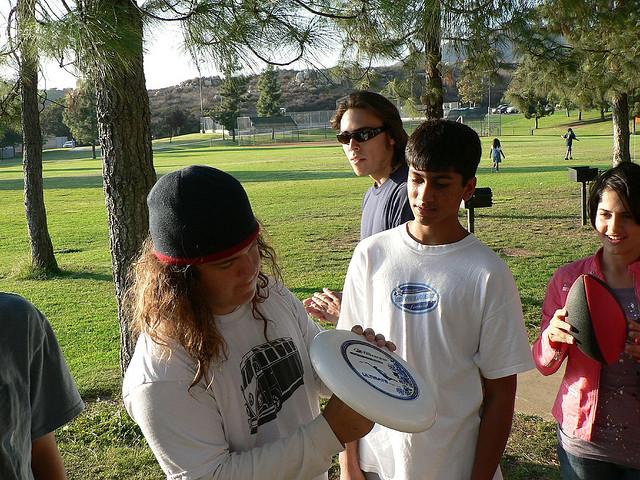Where is this?
Be succinct. Park. What is the man holding?
Short answer required. Frisbee. What color hat is the man wearing?
Quick response, please. Black. What kind of hat?
Answer briefly. Beanie. What is everybody looking at?
Concise answer only. Frisbee. What color is the striped shirt?
Write a very short answer. White. 